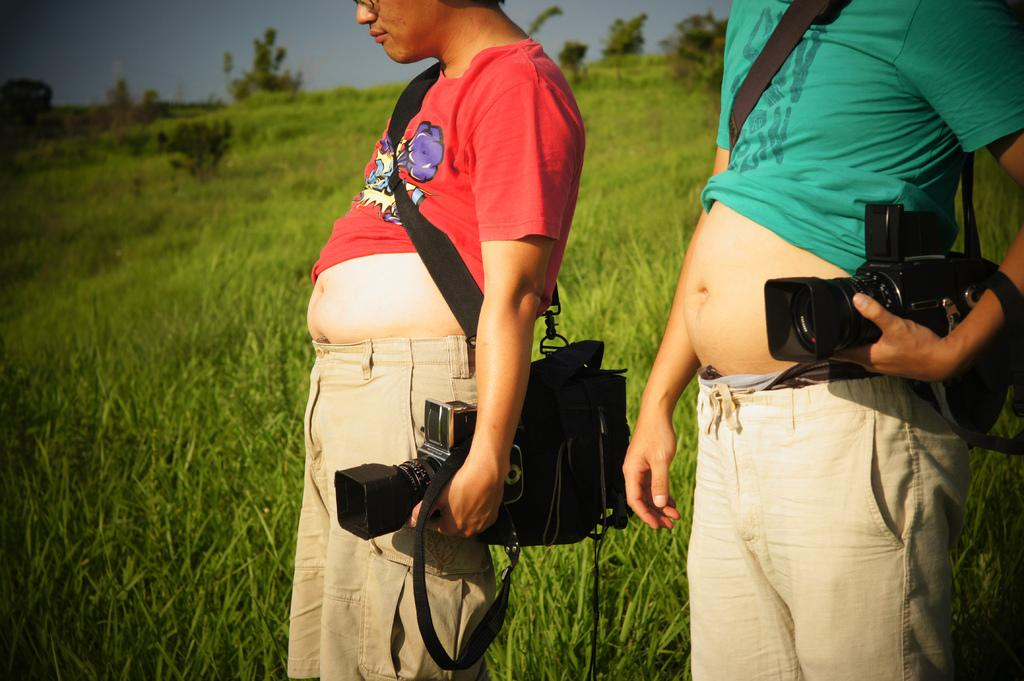How many people are in the image? There are two people in the image. What are the two people doing in the image? The two people are standing and holding a camera. What can be seen in the background of the image? There are trees and the sky visible in the background of the image. How many women are present in the image? The provided facts do not specify the gender of the two people in the image, so it cannot be determined if they are women or not. 